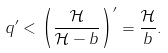Convert formula to latex. <formula><loc_0><loc_0><loc_500><loc_500>q ^ { \prime } < \left ( \frac { \mathcal { H } } { \mathcal { H } - b } \right ) ^ { \prime } = \frac { \mathcal { H } } { b } .</formula> 